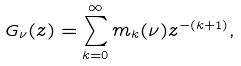Convert formula to latex. <formula><loc_0><loc_0><loc_500><loc_500>G _ { \nu } ( z ) = \sum _ { k = 0 } ^ { \infty } m _ { k } ( \nu ) z ^ { - ( k + 1 ) } ,</formula> 